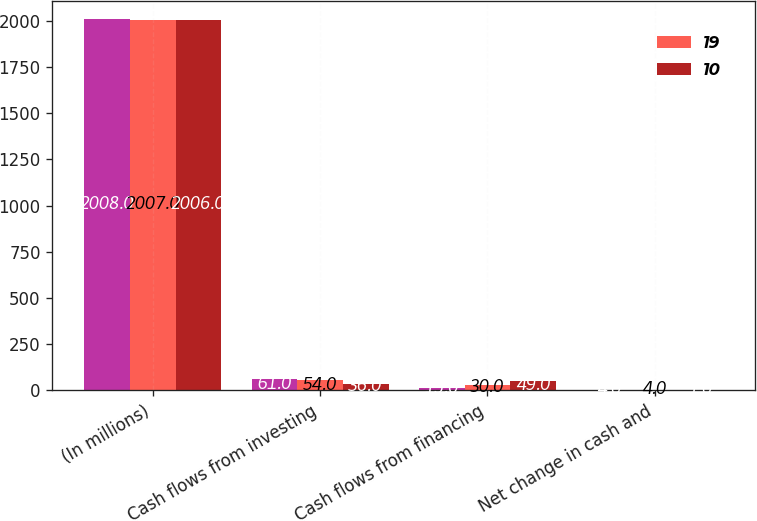Convert chart to OTSL. <chart><loc_0><loc_0><loc_500><loc_500><stacked_bar_chart><ecel><fcel>(In millions)<fcel>Cash flows from investing<fcel>Cash flows from financing<fcel>Net change in cash and<nl><fcel>nan<fcel>2008<fcel>61<fcel>15<fcel>4<nl><fcel>19<fcel>2007<fcel>54<fcel>30<fcel>4<nl><fcel>10<fcel>2006<fcel>36<fcel>49<fcel>1<nl></chart> 